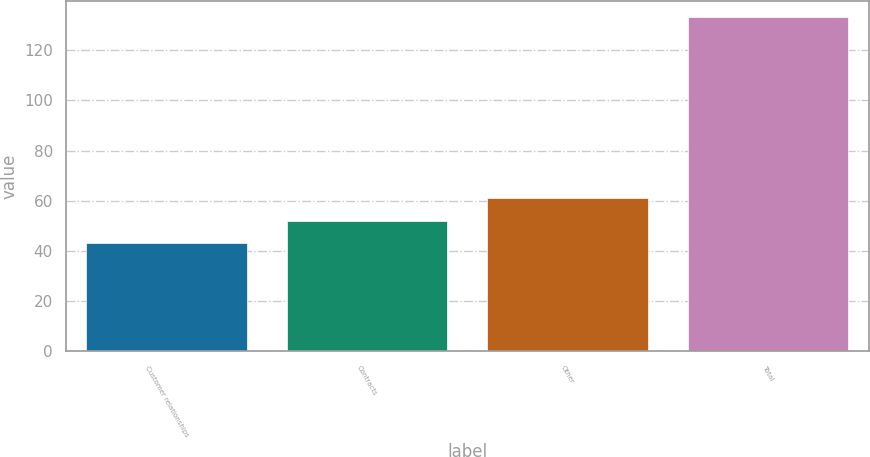<chart> <loc_0><loc_0><loc_500><loc_500><bar_chart><fcel>Customer relationships<fcel>Contracts<fcel>Other<fcel>Total<nl><fcel>43<fcel>52<fcel>61<fcel>133<nl></chart> 